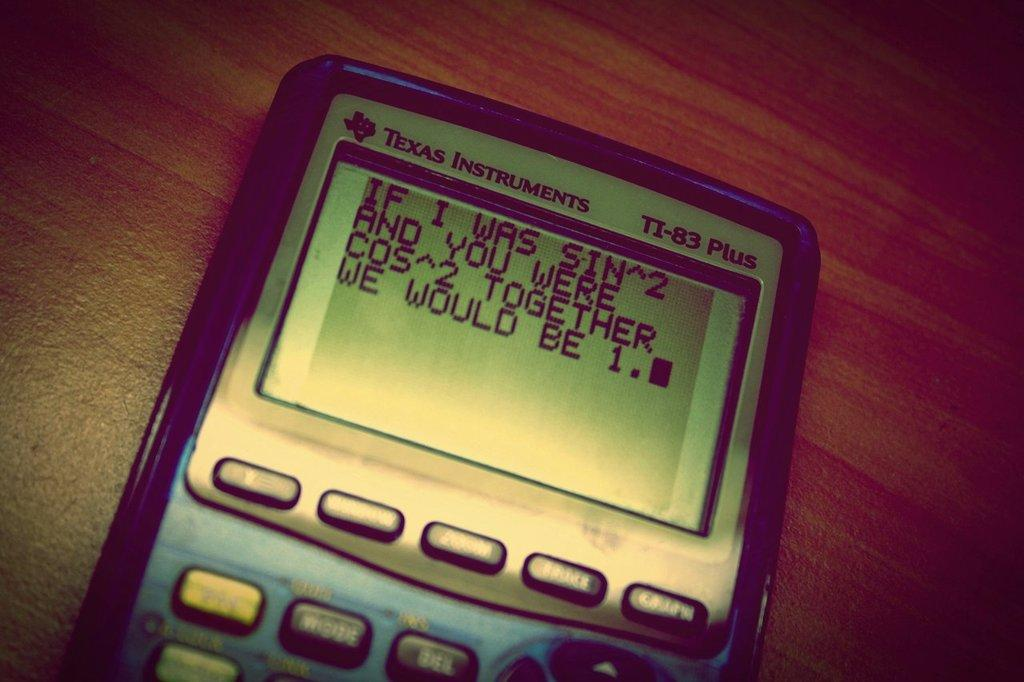Provide a one-sentence caption for the provided image. A math joke is displayed on the screen of a Texas Instruments device. 